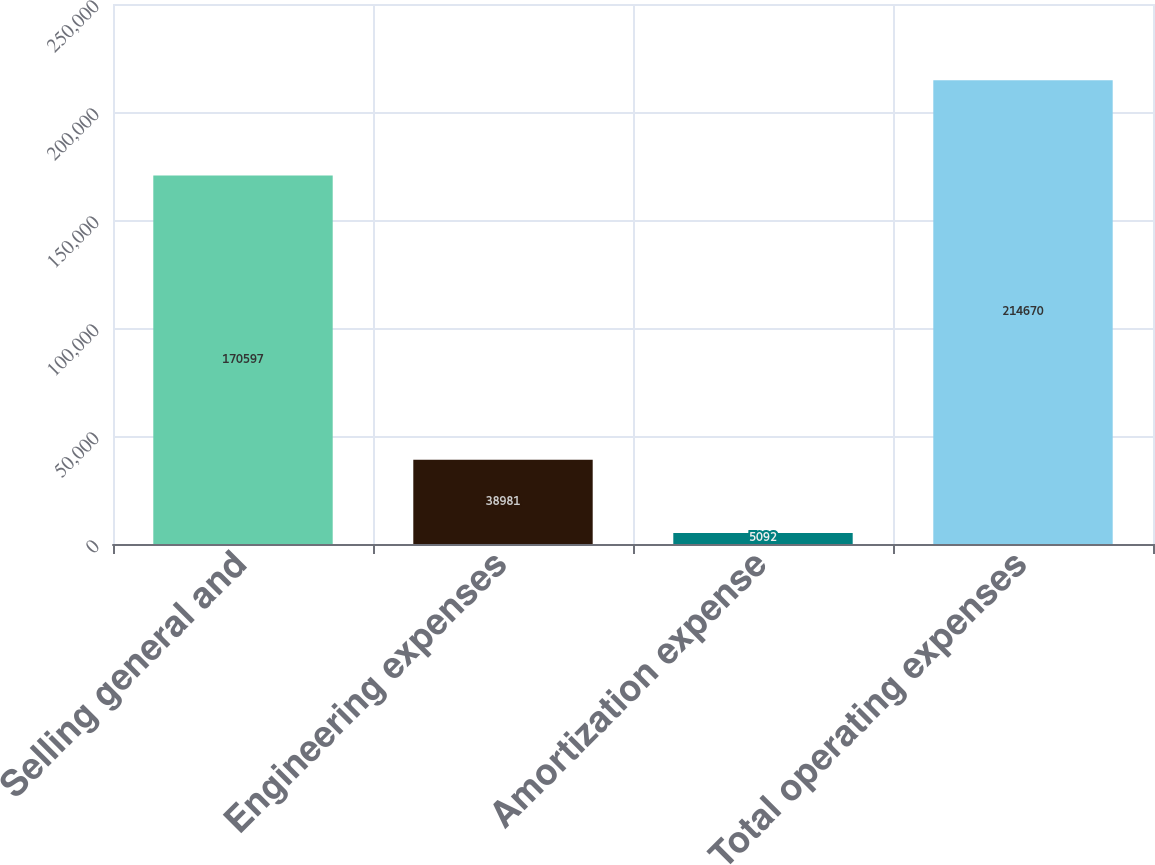Convert chart. <chart><loc_0><loc_0><loc_500><loc_500><bar_chart><fcel>Selling general and<fcel>Engineering expenses<fcel>Amortization expense<fcel>Total operating expenses<nl><fcel>170597<fcel>38981<fcel>5092<fcel>214670<nl></chart> 